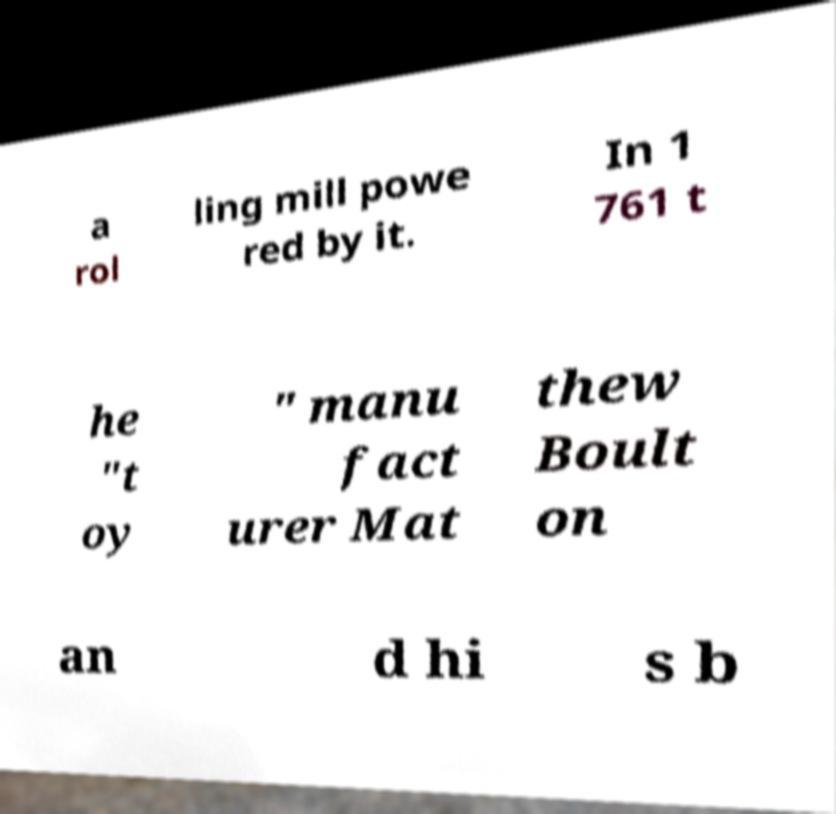Could you extract and type out the text from this image? a rol ling mill powe red by it. In 1 761 t he "t oy " manu fact urer Mat thew Boult on an d hi s b 